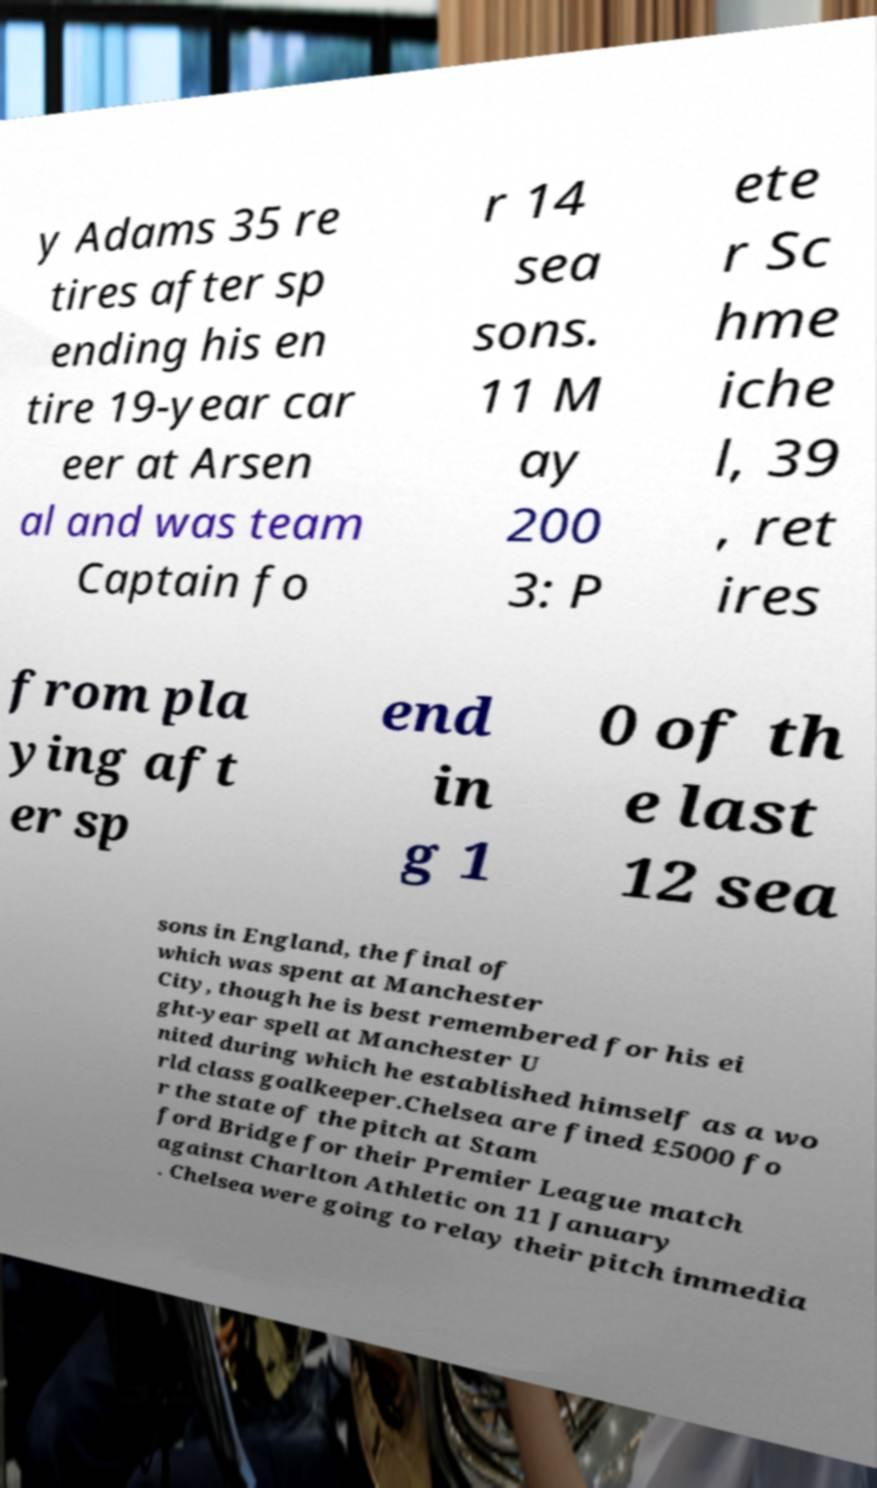Please identify and transcribe the text found in this image. y Adams 35 re tires after sp ending his en tire 19-year car eer at Arsen al and was team Captain fo r 14 sea sons. 11 M ay 200 3: P ete r Sc hme iche l, 39 , ret ires from pla ying aft er sp end in g 1 0 of th e last 12 sea sons in England, the final of which was spent at Manchester City, though he is best remembered for his ei ght-year spell at Manchester U nited during which he established himself as a wo rld class goalkeeper.Chelsea are fined £5000 fo r the state of the pitch at Stam ford Bridge for their Premier League match against Charlton Athletic on 11 January . Chelsea were going to relay their pitch immedia 